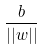<formula> <loc_0><loc_0><loc_500><loc_500>\frac { b } { | | w | | }</formula> 